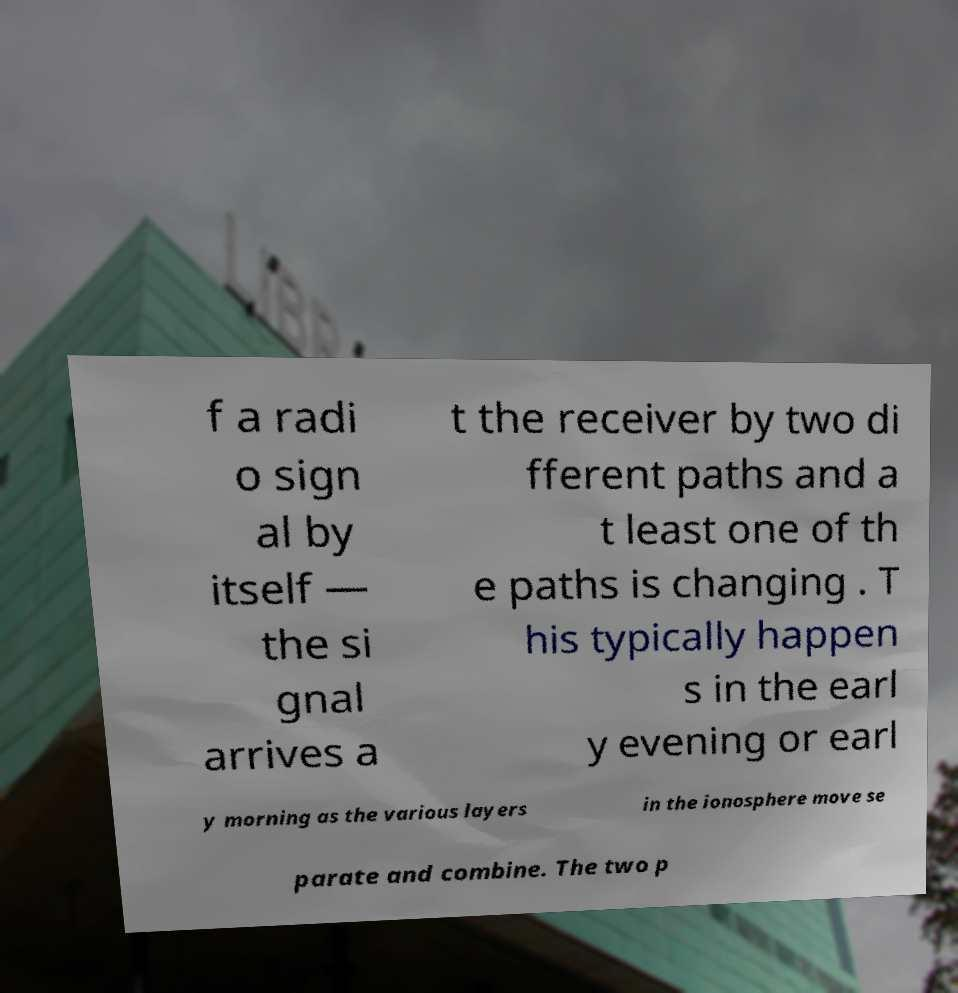Could you extract and type out the text from this image? f a radi o sign al by itself — the si gnal arrives a t the receiver by two di fferent paths and a t least one of th e paths is changing . T his typically happen s in the earl y evening or earl y morning as the various layers in the ionosphere move se parate and combine. The two p 